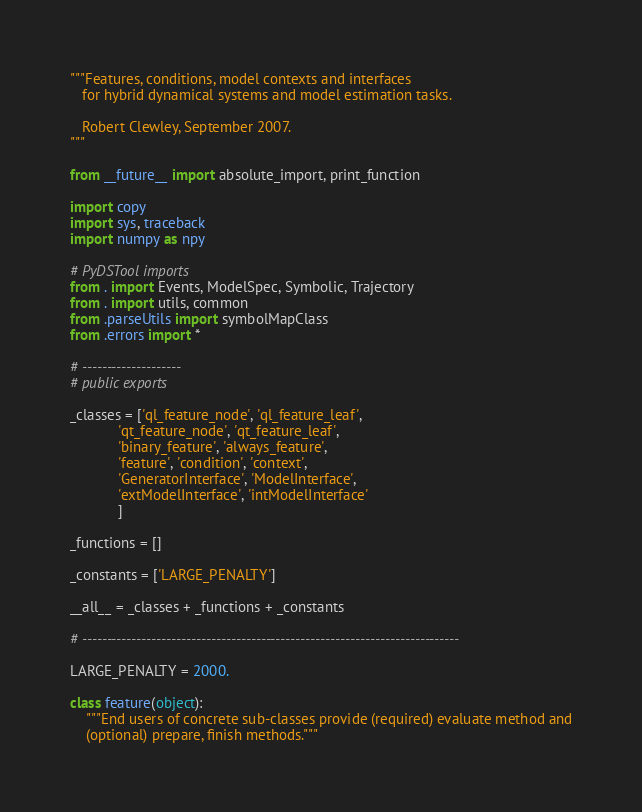Convert code to text. <code><loc_0><loc_0><loc_500><loc_500><_Python_>"""Features, conditions, model contexts and interfaces
   for hybrid dynamical systems and model estimation tasks.

   Robert Clewley, September 2007.
"""

from __future__ import absolute_import, print_function

import copy
import sys, traceback
import numpy as npy

# PyDSTool imports
from . import Events, ModelSpec, Symbolic, Trajectory
from . import utils, common
from .parseUtils import symbolMapClass
from .errors import *

# --------------------
# public exports

_classes = ['ql_feature_node', 'ql_feature_leaf',
            'qt_feature_node', 'qt_feature_leaf',
            'binary_feature', 'always_feature',
            'feature', 'condition', 'context',
            'GeneratorInterface', 'ModelInterface',
            'extModelInterface', 'intModelInterface'
            ]

_functions = []

_constants = ['LARGE_PENALTY']

__all__ = _classes + _functions + _constants

# ----------------------------------------------------------------------------

LARGE_PENALTY = 2000.

class feature(object):
    """End users of concrete sub-classes provide (required) evaluate method and
    (optional) prepare, finish methods."""</code> 